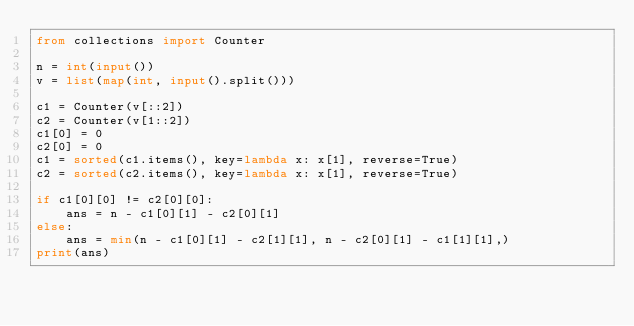<code> <loc_0><loc_0><loc_500><loc_500><_Python_>from collections import Counter

n = int(input())
v = list(map(int, input().split()))

c1 = Counter(v[::2])
c2 = Counter(v[1::2])
c1[0] = 0
c2[0] = 0
c1 = sorted(c1.items(), key=lambda x: x[1], reverse=True)
c2 = sorted(c2.items(), key=lambda x: x[1], reverse=True)

if c1[0][0] != c2[0][0]:
    ans = n - c1[0][1] - c2[0][1]
else:
    ans = min(n - c1[0][1] - c2[1][1], n - c2[0][1] - c1[1][1],)
print(ans)
</code> 